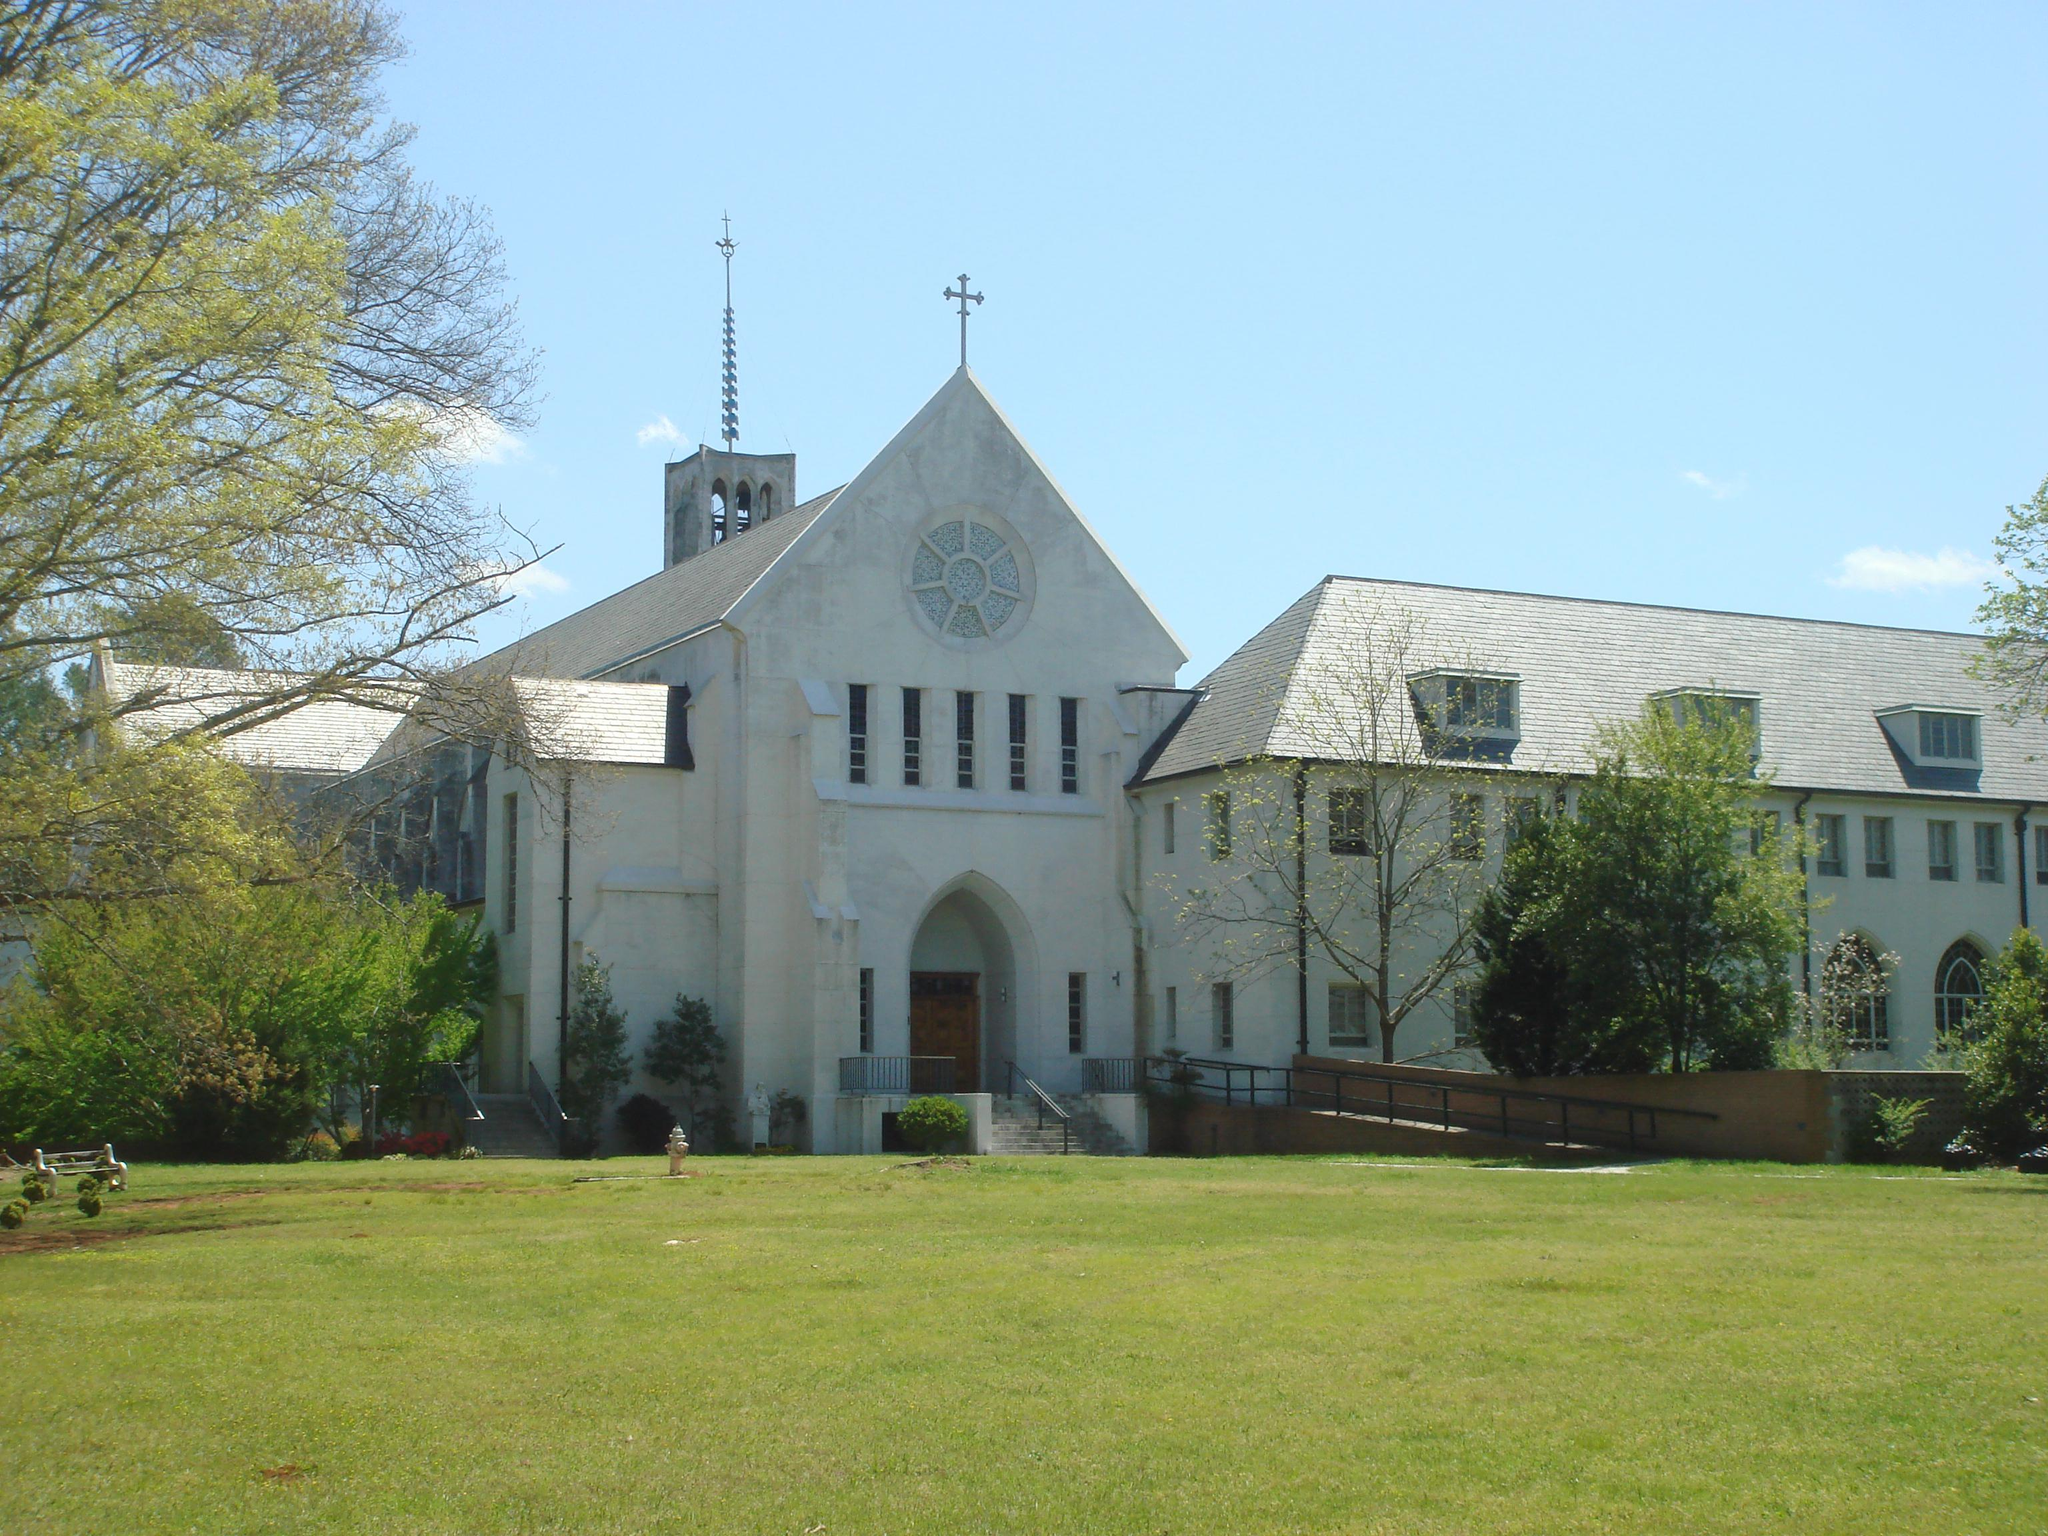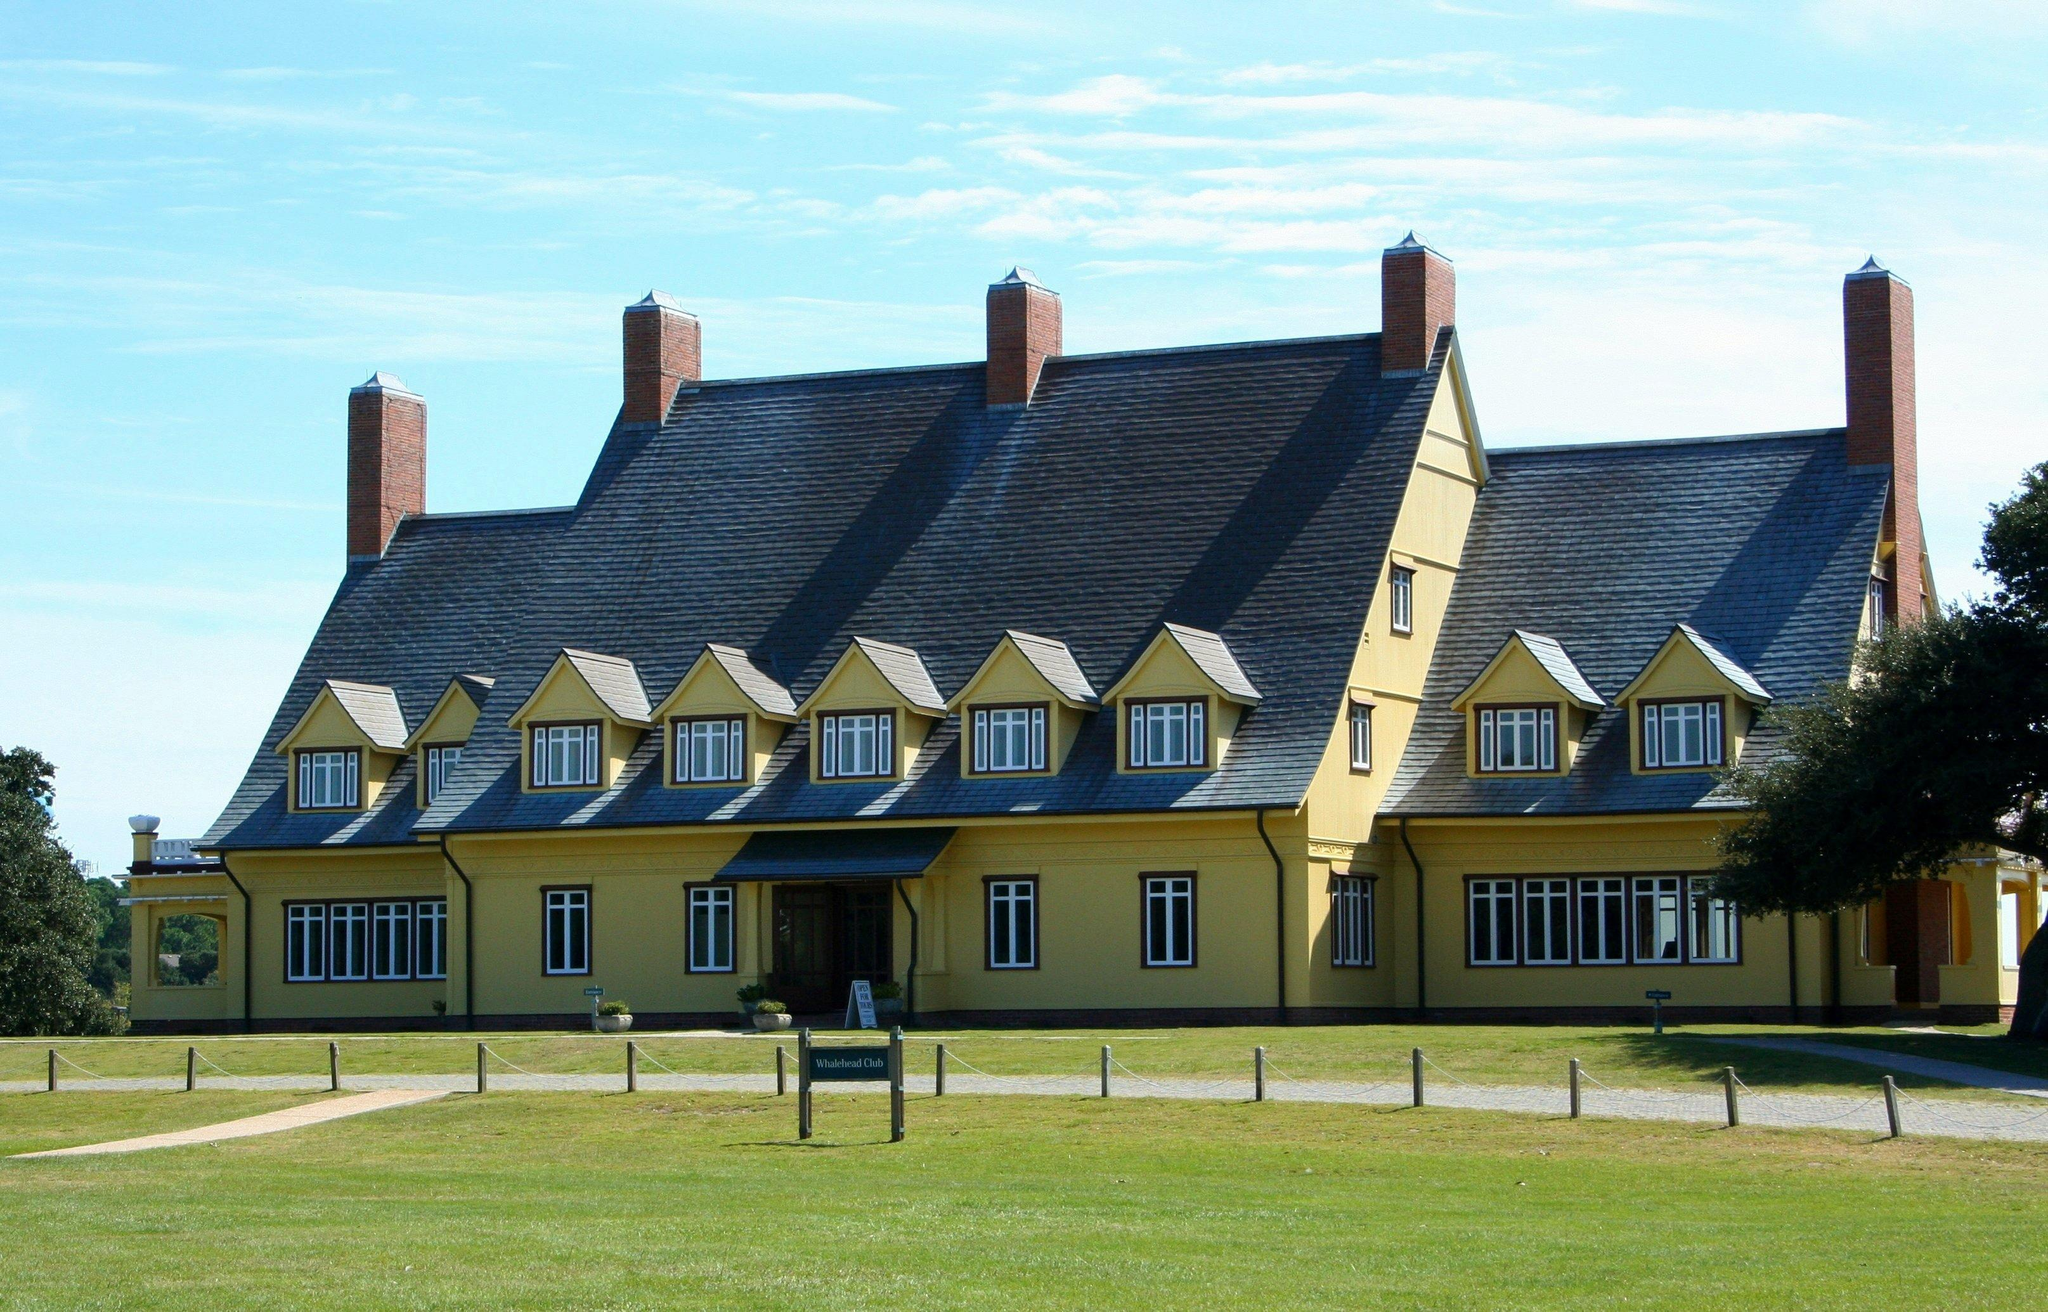The first image is the image on the left, the second image is the image on the right. Evaluate the accuracy of this statement regarding the images: "The building in the right image is yellow with a dark roof.". Is it true? Answer yes or no. Yes. 